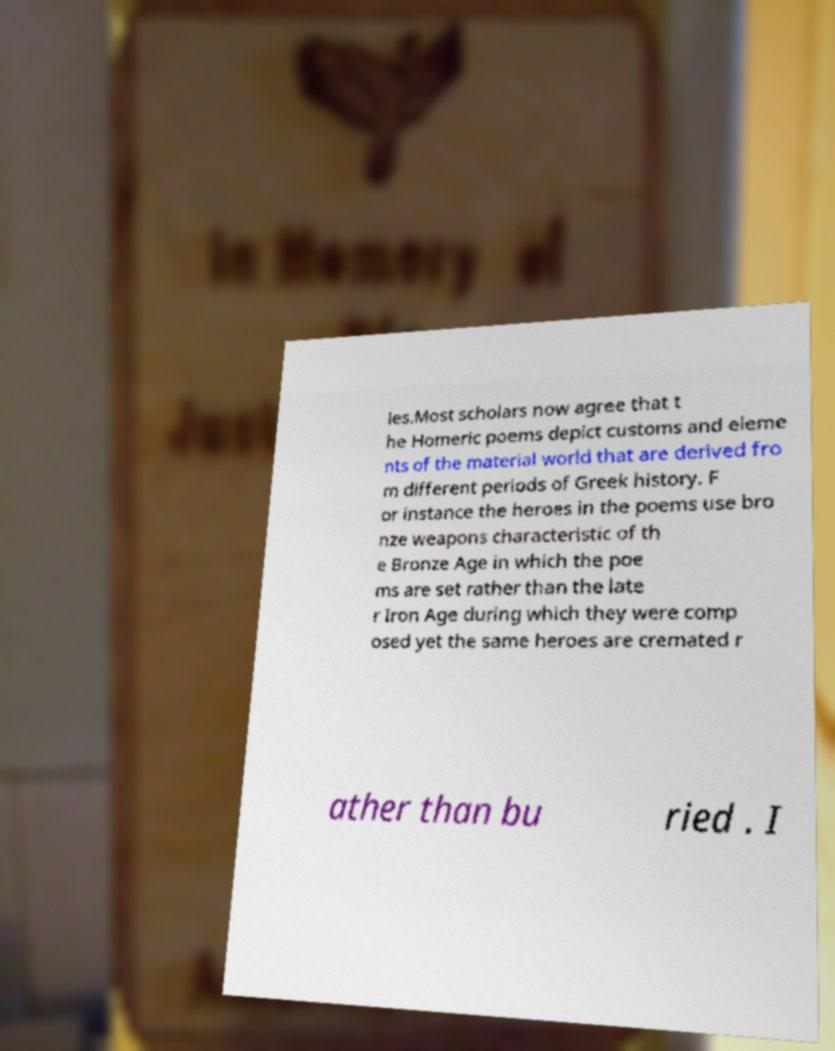Could you extract and type out the text from this image? ies.Most scholars now agree that t he Homeric poems depict customs and eleme nts of the material world that are derived fro m different periods of Greek history. F or instance the heroes in the poems use bro nze weapons characteristic of th e Bronze Age in which the poe ms are set rather than the late r Iron Age during which they were comp osed yet the same heroes are cremated r ather than bu ried . I 